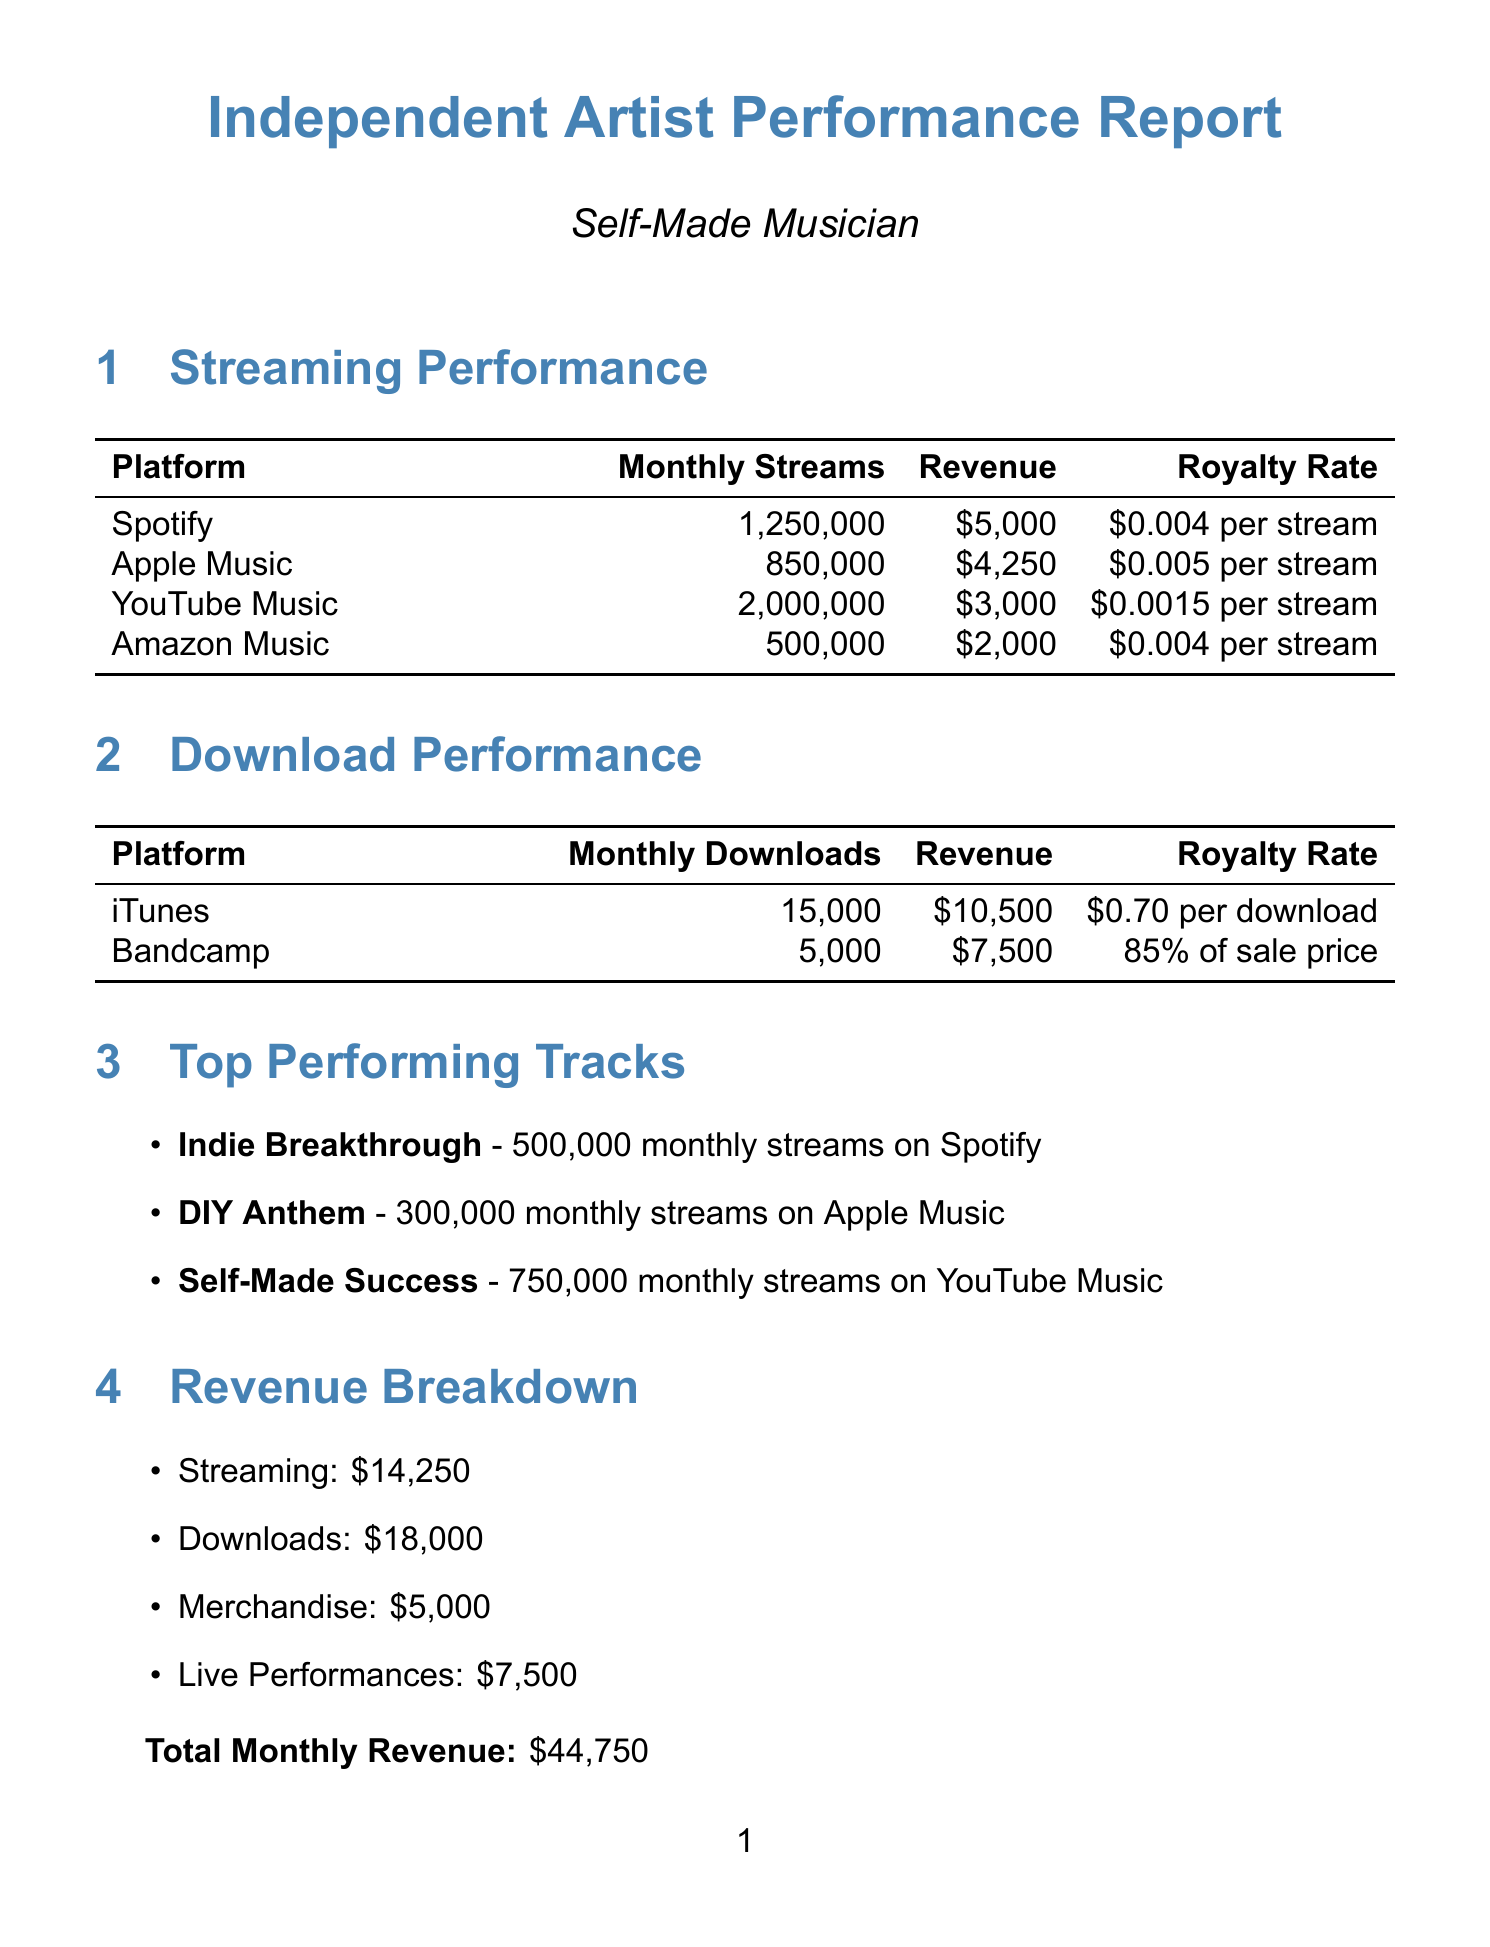What is the most streamed platform? The most streamed platform can be found in the streaming performance section, which lists monthly streams for each platform.
Answer: YouTube Music What is the monthly revenue from iTunes downloads? The revenue from iTunes downloads is stated directly in the download performance section.
Answer: $10500 What is the total monthly revenue? The total monthly revenue is the sum of all revenue sources mentioned in the revenue breakdown.
Answer: $44750 How many new TikTok followers were gained last month? The number of new TikTok followers is mentioned in the growth metrics section.
Answer: 50000 What percentage is the artist outperforming the average indie artist in monthly revenue? The document provides the percentage of performance comparison in comparison to the indie artist averages.
Answer: 1392% What promotional activity had an engagement rate? The specific promotional activity with an engagement rate is listed in the promotional activities section.
Answer: Social media campaign What is the estimated growth rate for the artist? The estimated growth rate is mentioned directly in the future projections section.
Answer: 15% per month What is the royalty rate per stream on Apple Music? The royalty rate per stream for Apple Music is provided in the streaming performance section.
Answer: $0.005 per stream 